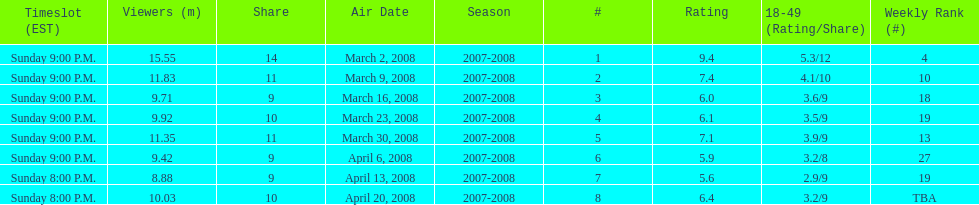How many shows had more than 10 million viewers? 4. 